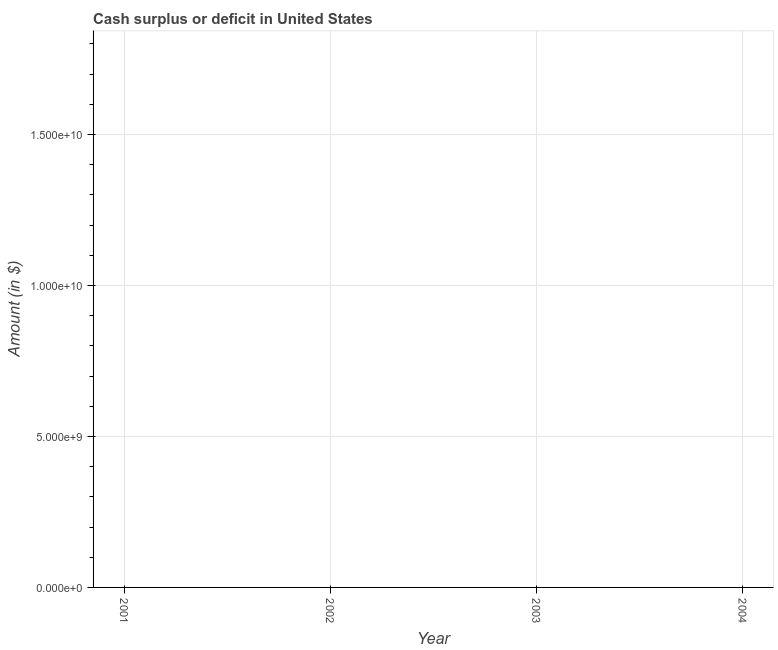Across all years, what is the minimum cash surplus or deficit?
Keep it short and to the point. 0. What is the median cash surplus or deficit?
Ensure brevity in your answer.  0. In how many years, is the cash surplus or deficit greater than 16000000000 $?
Your answer should be compact. 0. How many lines are there?
Offer a terse response. 0. What is the title of the graph?
Your answer should be very brief. Cash surplus or deficit in United States. What is the label or title of the Y-axis?
Keep it short and to the point. Amount (in $). What is the Amount (in $) of 2001?
Your answer should be compact. 0. What is the Amount (in $) in 2003?
Make the answer very short. 0. What is the Amount (in $) in 2004?
Your response must be concise. 0. 